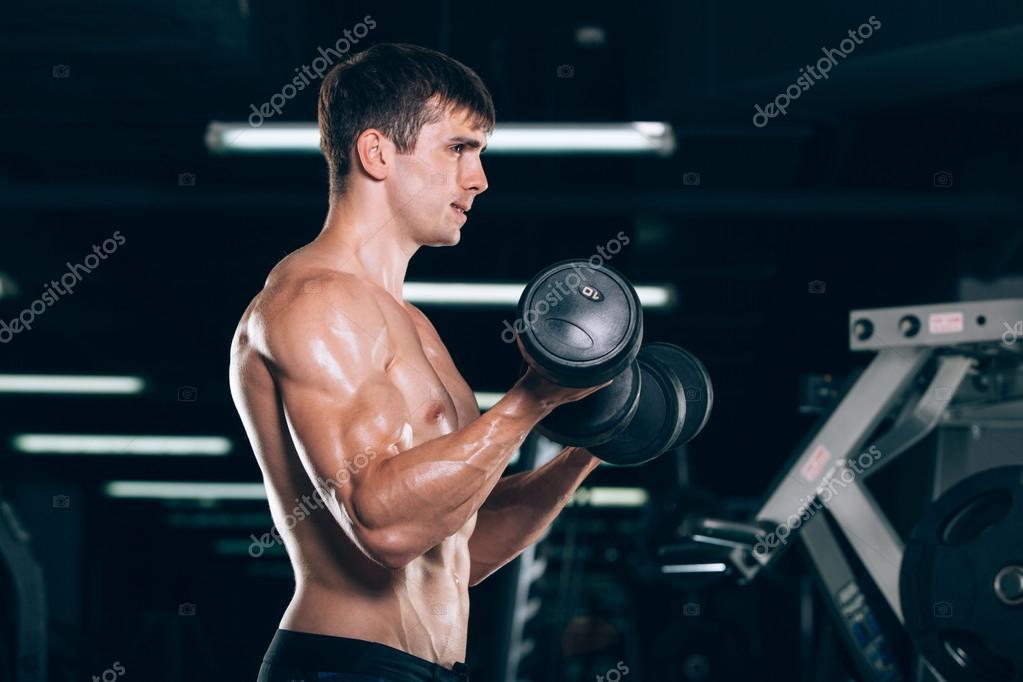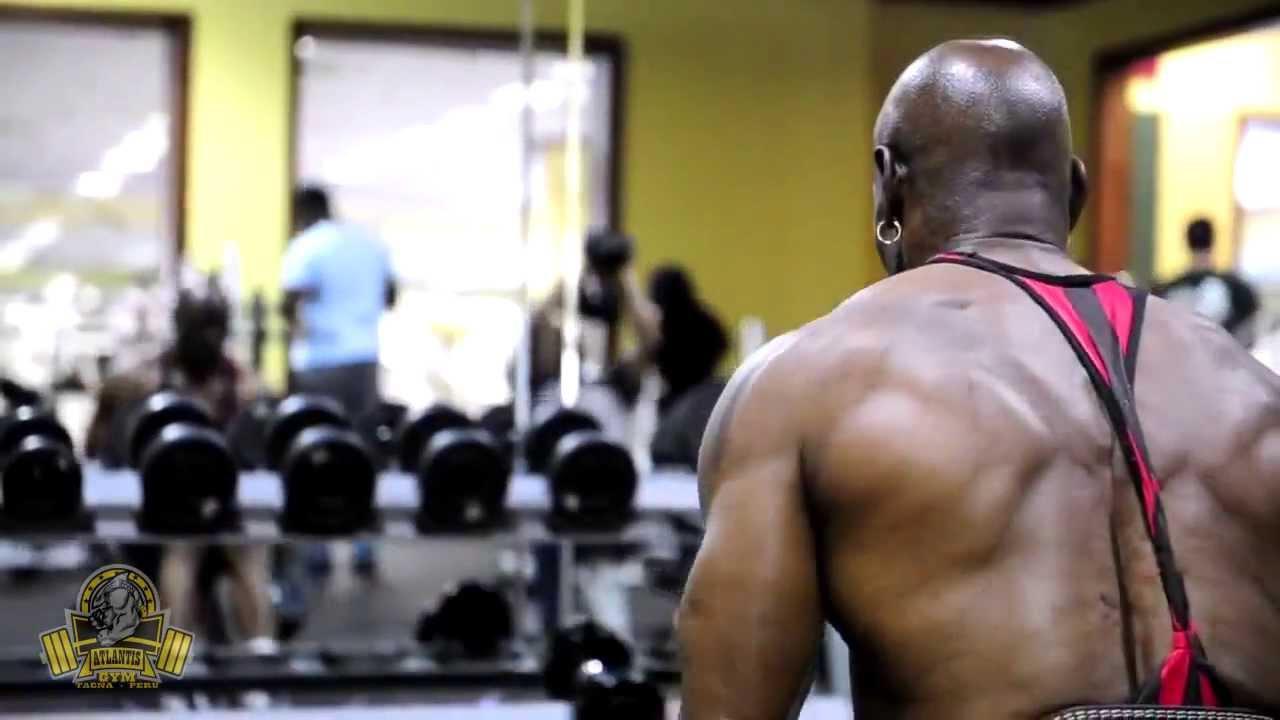The first image is the image on the left, the second image is the image on the right. Assess this claim about the two images: "The front of a male torso is facing toward the camera in the left image.". Correct or not? Answer yes or no. No. The first image is the image on the left, the second image is the image on the right. For the images shown, is this caption "Three dumbbells being held by men are visible." true? Answer yes or no. No. 